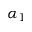Convert formula to latex. <formula><loc_0><loc_0><loc_500><loc_500>\alpha _ { 1 }</formula> 